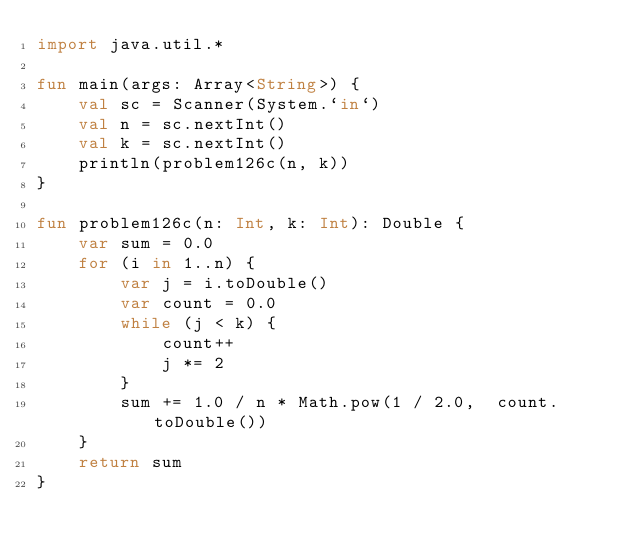Convert code to text. <code><loc_0><loc_0><loc_500><loc_500><_Kotlin_>import java.util.*

fun main(args: Array<String>) {
    val sc = Scanner(System.`in`)
    val n = sc.nextInt()
    val k = sc.nextInt()
    println(problem126c(n, k))
}

fun problem126c(n: Int, k: Int): Double {
    var sum = 0.0
    for (i in 1..n) {
        var j = i.toDouble()
        var count = 0.0
        while (j < k) {
            count++
            j *= 2
        }
        sum += 1.0 / n * Math.pow(1 / 2.0,  count.toDouble())
    }
    return sum
}</code> 